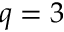Convert formula to latex. <formula><loc_0><loc_0><loc_500><loc_500>q = 3</formula> 